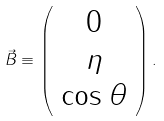Convert formula to latex. <formula><loc_0><loc_0><loc_500><loc_500>\vec { B } \equiv \left ( \begin{array} { c } 0 \\ \eta \\ \cos \theta \end{array} \right ) .</formula> 